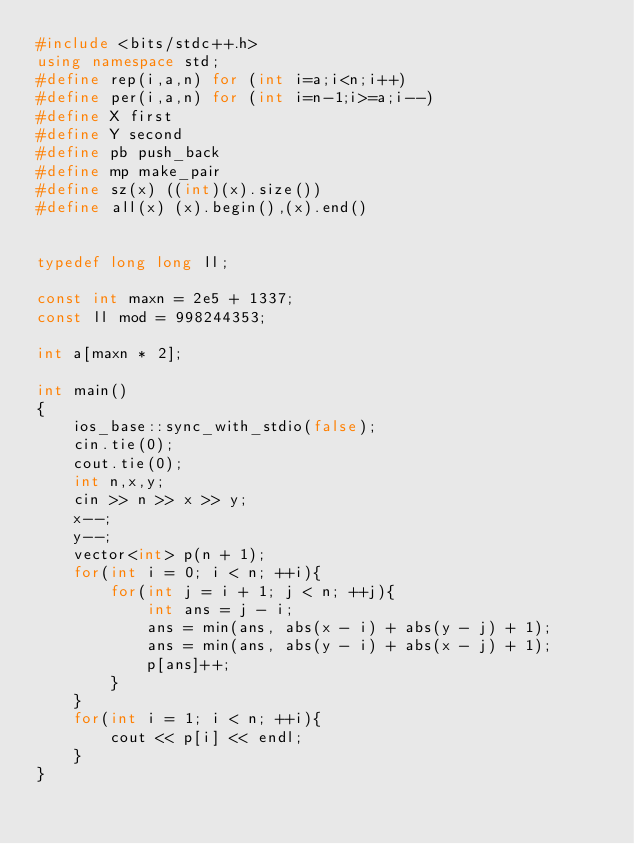Convert code to text. <code><loc_0><loc_0><loc_500><loc_500><_C++_>#include <bits/stdc++.h>
using namespace std;
#define rep(i,a,n) for (int i=a;i<n;i++)
#define per(i,a,n) for (int i=n-1;i>=a;i--)
#define X first
#define Y second
#define pb push_back
#define mp make_pair
#define sz(x) ((int)(x).size())
#define all(x) (x).begin(),(x).end()


typedef long long ll;

const int maxn = 2e5 + 1337;
const ll mod = 998244353;

int a[maxn * 2];

int main()
{
    ios_base::sync_with_stdio(false);
    cin.tie(0);
    cout.tie(0);
    int n,x,y;
    cin >> n >> x >> y;
    x--;
    y--;
    vector<int> p(n + 1);
    for(int i = 0; i < n; ++i){
        for(int j = i + 1; j < n; ++j){
            int ans = j - i;
            ans = min(ans, abs(x - i) + abs(y - j) + 1);
            ans = min(ans, abs(y - i) + abs(x - j) + 1);
            p[ans]++;
        }
    }
    for(int i = 1; i < n; ++i){
        cout << p[i] << endl;
    }
}
</code> 